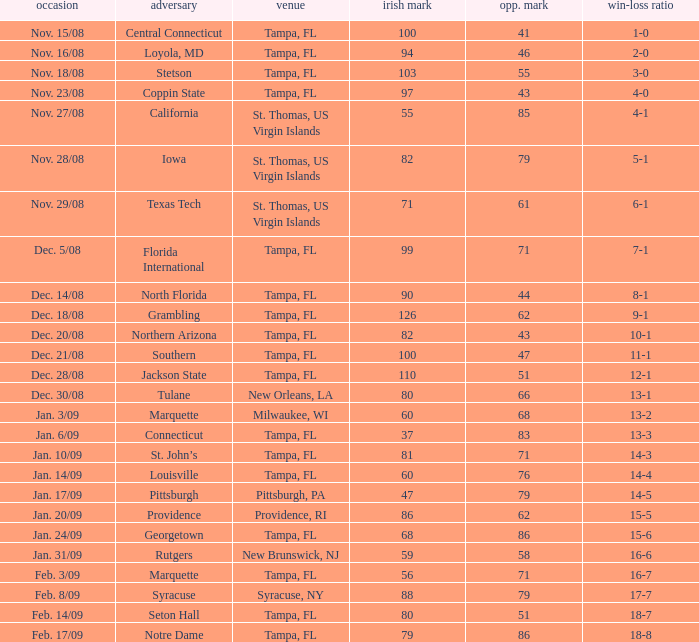What is the record where the locaiton is tampa, fl and the opponent is louisville? 14-4. 